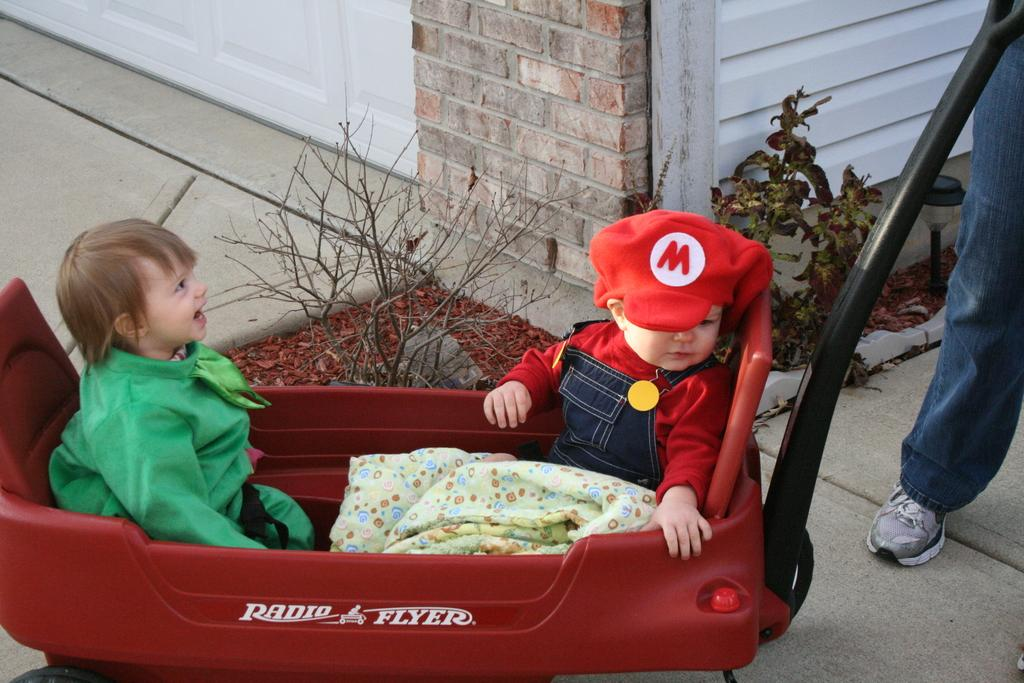What are the kids doing in the image? The two kids are sitting in a trolley. Who is near the trolley? There is a man near the trolley. What can be seen behind the trolley? There are plants and a wall visible behind the trolley. Can you see the kids' friend, the robin, sitting on the trolley with them? There is no robin present in the image; it only features the two kids sitting in the trolley and a man nearby. 